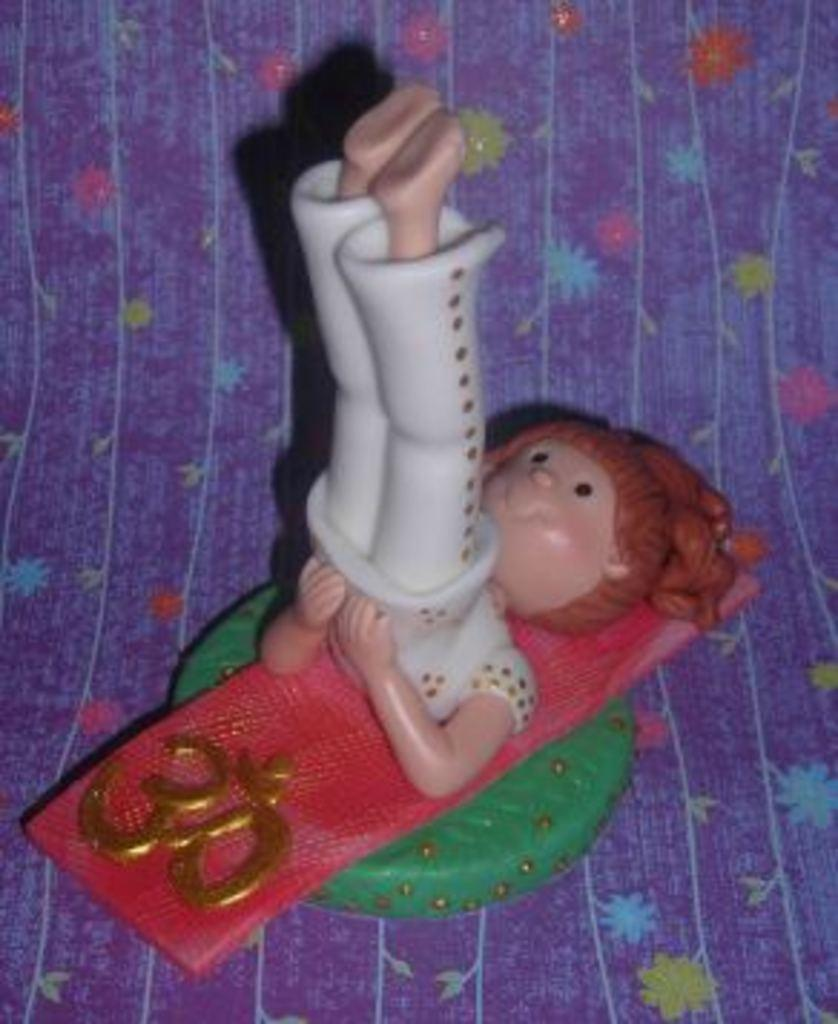What is the main subject of the image? There is a doll in the image. How is the doll positioned in the image? The doll is placed on a cloth. What color is the cloth that the doll is placed on? The cloth is blue in color. What is the doll wearing in the image? The doll is wearing a white dress. What type of alarm is the doll requesting in the image? There is no alarm or request present in the image; it features a doll placed on a blue cloth and wearing a white dress. 